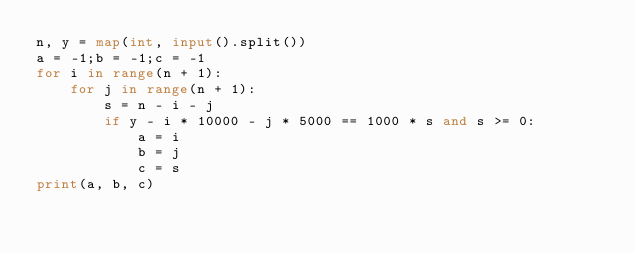Convert code to text. <code><loc_0><loc_0><loc_500><loc_500><_Python_>n, y = map(int, input().split())
a = -1;b = -1;c = -1
for i in range(n + 1):
    for j in range(n + 1):
        s = n - i - j
        if y - i * 10000 - j * 5000 == 1000 * s and s >= 0:
            a = i
            b = j
            c = s
print(a, b, c)
</code> 